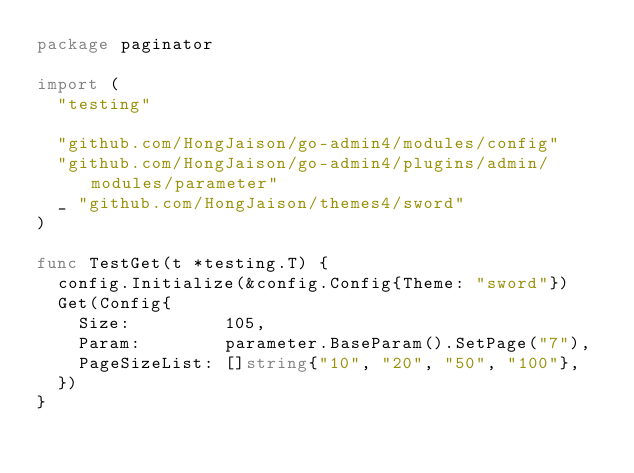Convert code to text. <code><loc_0><loc_0><loc_500><loc_500><_Go_>package paginator

import (
	"testing"

	"github.com/HongJaison/go-admin4/modules/config"
	"github.com/HongJaison/go-admin4/plugins/admin/modules/parameter"
	_ "github.com/HongJaison/themes4/sword"
)

func TestGet(t *testing.T) {
	config.Initialize(&config.Config{Theme: "sword"})
	Get(Config{
		Size:         105,
		Param:        parameter.BaseParam().SetPage("7"),
		PageSizeList: []string{"10", "20", "50", "100"},
	})
}
</code> 